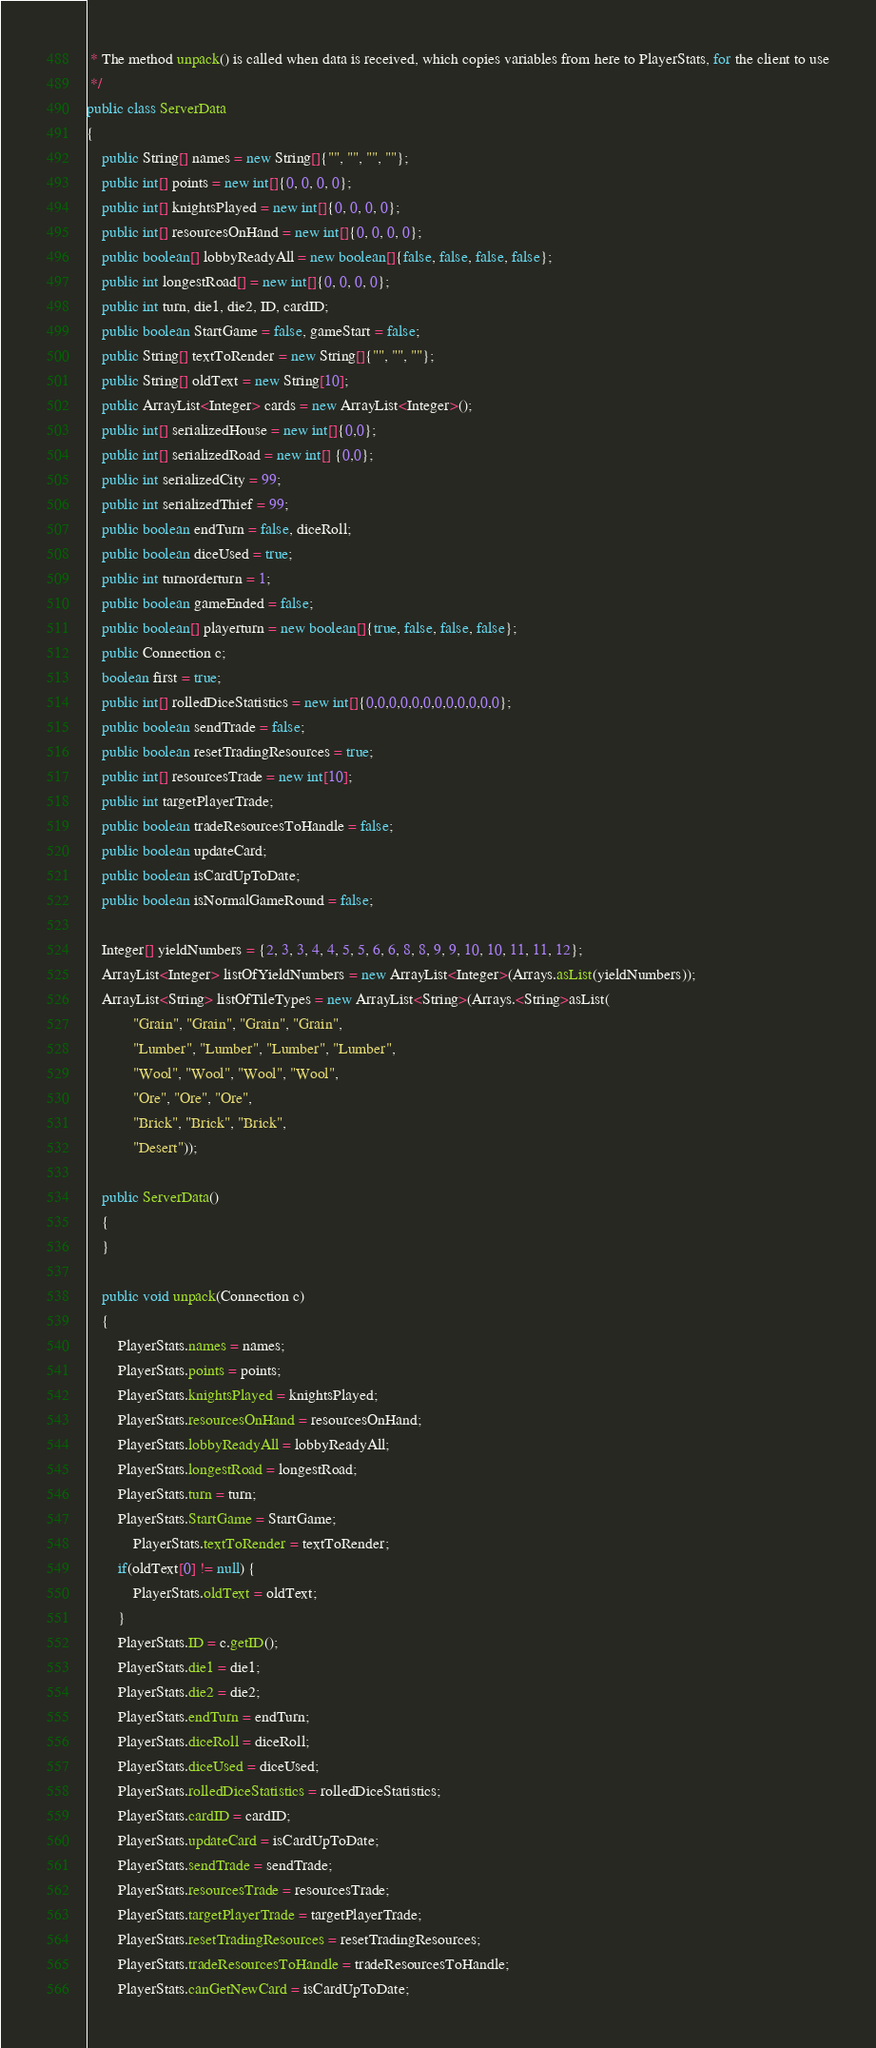Convert code to text. <code><loc_0><loc_0><loc_500><loc_500><_Java_> * The method unpack() is called when data is received, which copies variables from here to PlayerStats, for the client to use
 */
public class ServerData
{
    public String[] names = new String[]{"", "", "", ""};
    public int[] points = new int[]{0, 0, 0, 0};
    public int[] knightsPlayed = new int[]{0, 0, 0, 0};
    public int[] resourcesOnHand = new int[]{0, 0, 0, 0};
    public boolean[] lobbyReadyAll = new boolean[]{false, false, false, false};
    public int longestRoad[] = new int[]{0, 0, 0, 0};
    public int turn, die1, die2, ID, cardID;
    public boolean StartGame = false, gameStart = false;
    public String[] textToRender = new String[]{"", "", ""};
    public String[] oldText = new String[10];
    public ArrayList<Integer> cards = new ArrayList<Integer>();
    public int[] serializedHouse = new int[]{0,0};
    public int[] serializedRoad = new int[] {0,0};
    public int serializedCity = 99;
    public int serializedThief = 99;
    public boolean endTurn = false, diceRoll;
    public boolean diceUsed = true;
    public int turnorderturn = 1;
    public boolean gameEnded = false;
    public boolean[] playerturn = new boolean[]{true, false, false, false};
    public Connection c;
    boolean first = true;
    public int[] rolledDiceStatistics = new int[]{0,0,0,0,0,0,0,0,0,0,0,0};
    public boolean sendTrade = false;
    public boolean resetTradingResources = true;
    public int[] resourcesTrade = new int[10];
    public int targetPlayerTrade;
    public boolean tradeResourcesToHandle = false;
    public boolean updateCard;
    public boolean isCardUpToDate;
    public boolean isNormalGameRound = false;

    Integer[] yieldNumbers = {2, 3, 3, 4, 4, 5, 5, 6, 6, 8, 8, 9, 9, 10, 10, 11, 11, 12};
    ArrayList<Integer> listOfYieldNumbers = new ArrayList<Integer>(Arrays.asList(yieldNumbers));
    ArrayList<String> listOfTileTypes = new ArrayList<String>(Arrays.<String>asList(
            "Grain", "Grain", "Grain", "Grain",
            "Lumber", "Lumber", "Lumber", "Lumber",
            "Wool", "Wool", "Wool", "Wool",
            "Ore", "Ore", "Ore",
            "Brick", "Brick", "Brick",
            "Desert"));

    public ServerData()
    {
    }

    public void unpack(Connection c)
    {
        PlayerStats.names = names;
        PlayerStats.points = points;
        PlayerStats.knightsPlayed = knightsPlayed;
        PlayerStats.resourcesOnHand = resourcesOnHand;
        PlayerStats.lobbyReadyAll = lobbyReadyAll;
        PlayerStats.longestRoad = longestRoad;
        PlayerStats.turn = turn;
        PlayerStats.StartGame = StartGame;
            PlayerStats.textToRender = textToRender;
        if(oldText[0] != null) {
            PlayerStats.oldText = oldText;
        }
        PlayerStats.ID = c.getID();
        PlayerStats.die1 = die1;
        PlayerStats.die2 = die2;
        PlayerStats.endTurn = endTurn;
        PlayerStats.diceRoll = diceRoll;
        PlayerStats.diceUsed = diceUsed;
        PlayerStats.rolledDiceStatistics = rolledDiceStatistics;
        PlayerStats.cardID = cardID;
        PlayerStats.updateCard = isCardUpToDate;
        PlayerStats.sendTrade = sendTrade;
        PlayerStats.resourcesTrade = resourcesTrade;
        PlayerStats.targetPlayerTrade = targetPlayerTrade;
        PlayerStats.resetTradingResources = resetTradingResources;
        PlayerStats.tradeResourcesToHandle = tradeResourcesToHandle;
        PlayerStats.canGetNewCard = isCardUpToDate;</code> 